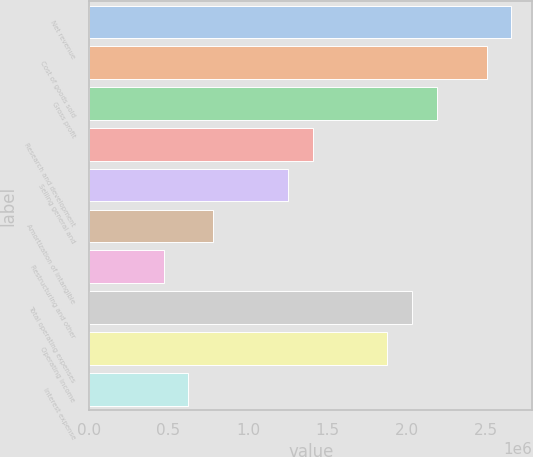<chart> <loc_0><loc_0><loc_500><loc_500><bar_chart><fcel>Net revenue<fcel>Cost of goods sold<fcel>Gross profit<fcel>Research and development<fcel>Selling general and<fcel>Amortization of intangible<fcel>Restructuring and other<fcel>Total operating expenses<fcel>Operating income<fcel>Interest expense<nl><fcel>2.65889e+06<fcel>2.50248e+06<fcel>2.18967e+06<fcel>1.40765e+06<fcel>1.25124e+06<fcel>782026<fcel>469216<fcel>2.03327e+06<fcel>1.87686e+06<fcel>625621<nl></chart> 